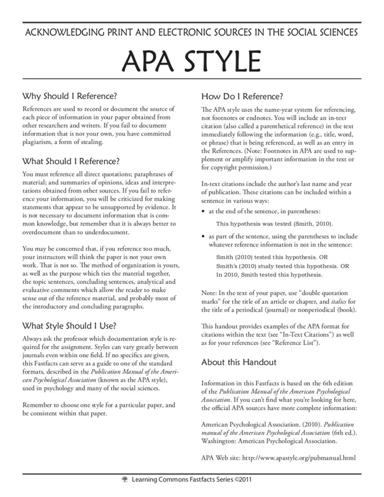What is the main subject of the text in the image? The text in the image primarily discusses the proper methods of acknowledging both print and electronic sources in the social sciences using APA style. It outlines effective strategies for correctly citing these sources, which is essential for academic integrity and scholarly communication. 